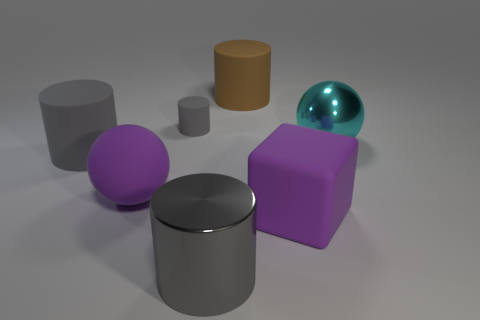How many gray cylinders must be subtracted to get 1 gray cylinders? 2 Subtract all gray cubes. How many gray cylinders are left? 3 Subtract all brown cylinders. How many cylinders are left? 3 Add 1 gray shiny objects. How many objects exist? 8 Subtract all yellow cylinders. Subtract all yellow balls. How many cylinders are left? 4 Subtract all cubes. How many objects are left? 6 Subtract all gray cylinders. Subtract all large metallic cylinders. How many objects are left? 3 Add 6 large brown rubber things. How many large brown rubber things are left? 7 Add 2 large matte balls. How many large matte balls exist? 3 Subtract 0 cyan cylinders. How many objects are left? 7 